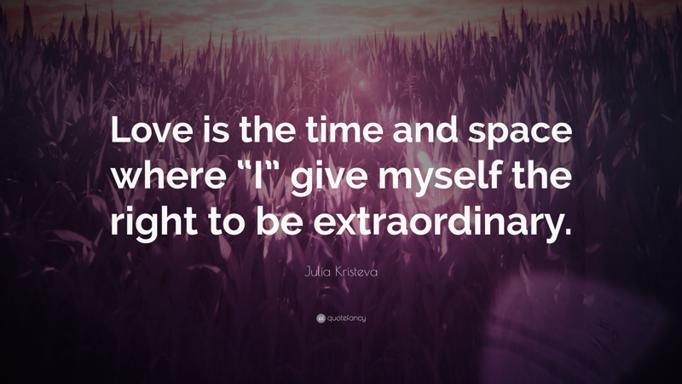What is the quote in the image that mentions love? The quote in the image states, "Love is the time and space where 'I' give myself the right to be extraordinary." This poignant statement by Julia Kristeva highlights how love can transform personal limitations into opportunities for greatness, emphasizing its empowering effect. 